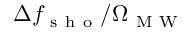Convert formula to latex. <formula><loc_0><loc_0><loc_500><loc_500>\Delta f _ { s h o } / \Omega _ { M W }</formula> 